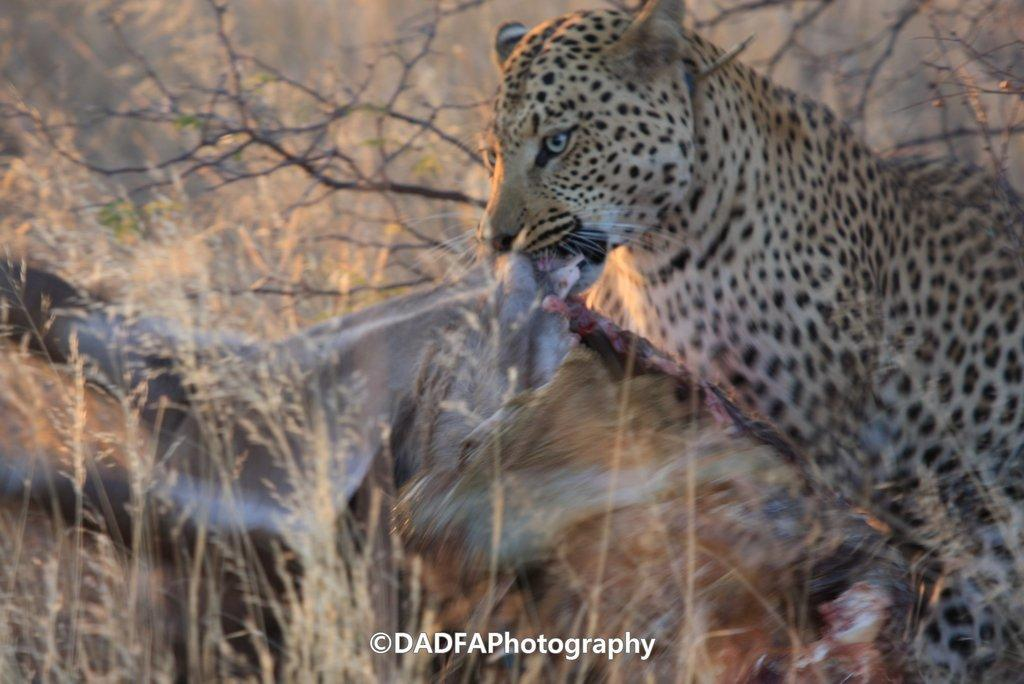What animal is the main subject of the image? There is a cheetah in the image. What is the cheetah doing in the image? The cheetah is eating an animal. What can be seen in the background of the image? There are trees in the background of the image. Is there any text or logo visible on the image? Yes, there is a watermark on the image. What type of flowers can be seen growing near the cheetah in the image? There are no flowers visible in the image; it features a cheetah eating an animal with trees in the background. 